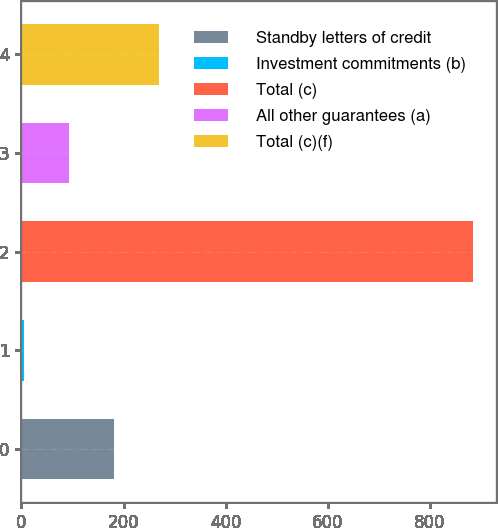Convert chart to OTSL. <chart><loc_0><loc_0><loc_500><loc_500><bar_chart><fcel>Standby letters of credit<fcel>Investment commitments (b)<fcel>Total (c)<fcel>All other guarantees (a)<fcel>Total (c)(f)<nl><fcel>181<fcel>5<fcel>885<fcel>93<fcel>269<nl></chart> 